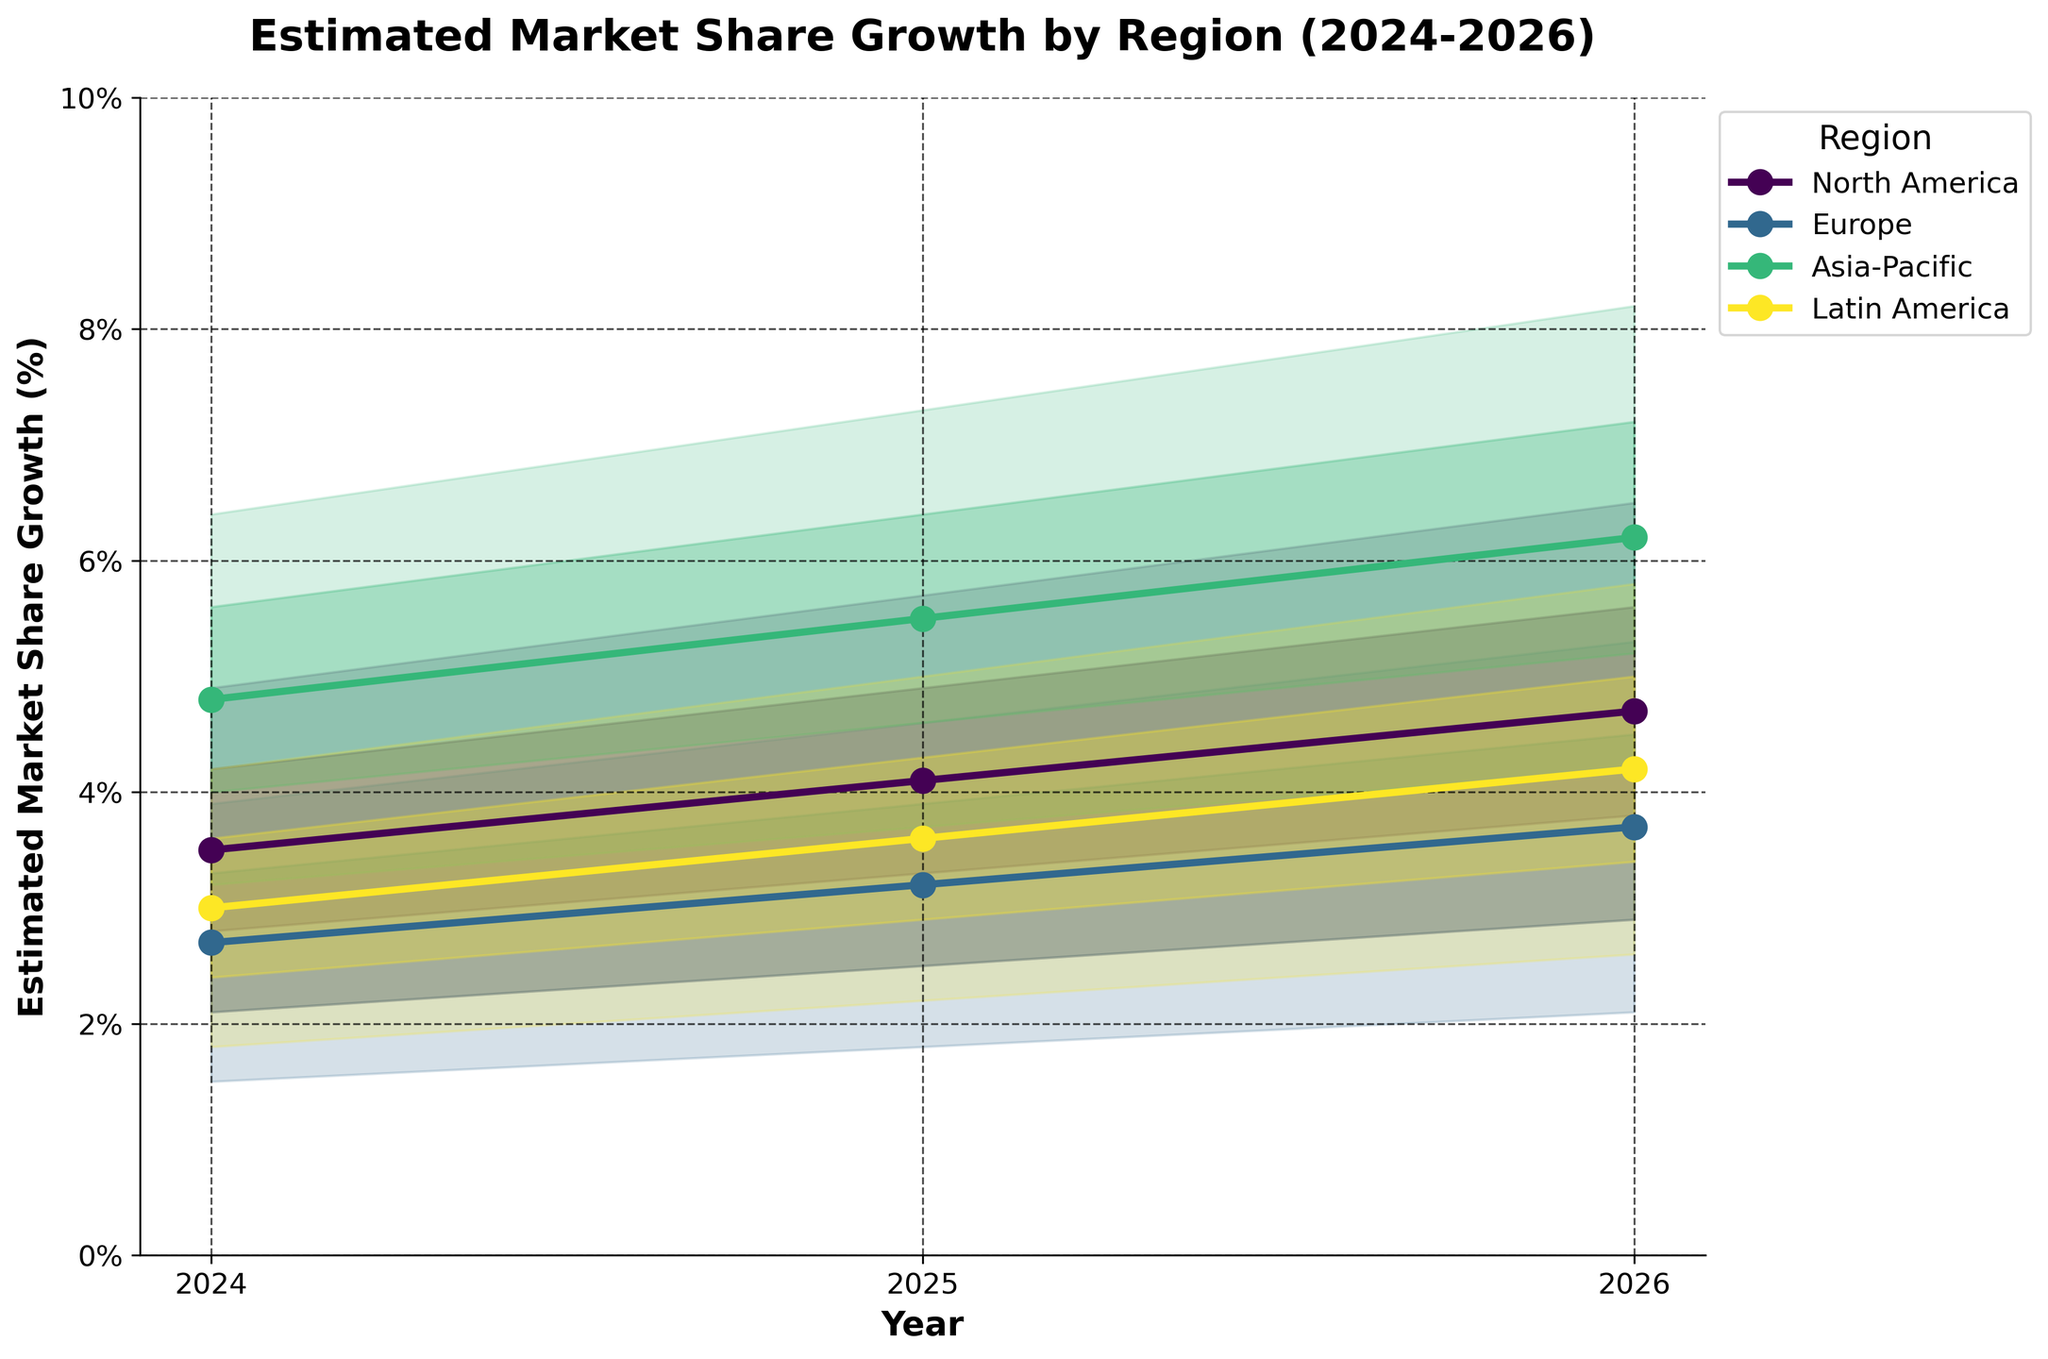What is the title of the chart? The title is usually located at the top of the chart and clearly states the main focus.
Answer: Estimated Market Share Growth by Region (2024-2026) What are the estimated market share growth values for North America in 2025? Look at the data points and bands corresponding to North America in the year 2025. The values fall between the Low (2.5%) and High (5.7%) bands, with Mid value as the central estimate (4.1%).
Answer: Between 2.5% and 5.7%, with 4.1% as the central estimate Which region has the highest estimated market share growth in 2026? Identify the uppermost Mid value in 2026 across all regions. Asia-Pacific shows the highest value with a Mid estimate of 6.2%.
Answer: Asia-Pacific How does the estimated market share growth for Latin America in 2026 compare to that in 2025? Compare the Mid values for Latin America between 2025 and 2026. The Mid value increases from 3.6% in 2025 to 4.2% in 2026.
Answer: It increases from 3.6% to 4.2% Which year shows the lowest growth estimate for Europe and what is the value? Identify the year with the lowest Mid value for Europe. This value is 2.7% in 2024.
Answer: 2024 with 2.7% For Asia-Pacific in 2025, what is the range of most likely market share growth estimates? Refer to the Mid-High and Low-Mid bands for Asia-Pacific in 2025. These values span from 4.6% to 6.4%.
Answer: Between 4.6% and 6.4% Which region shows a consistent increase in Market Share Growth from 2024 to 2026? Analyze the trend lines for each region over the years. North America and Asia-Pacific show consistent increases.
Answer: North America and Asia-Pacific What is the difference between the highest and lowest estimated growth for North America in 2024? Subtract the Low value from the High value for North America in 2024: 4.9% - 2.1%.
Answer: 2.8% Between Europe and Latin America, which region has a higher Mid value in 2025? Compare the Mid values of Europe (3.2%) and Latin America (3.6%) for 2025.
Answer: Latin America What is the average Mid value for Asia-Pacific across 2024, 2025, and 2026? Add the Mid values for Asia-Pacific for the years 2024 (4.8), 2025 (5.5), and 2026 (6.2) and then divide by 3: (4.8 + 5.5 + 6.2) / 3.
Answer: 5.5 